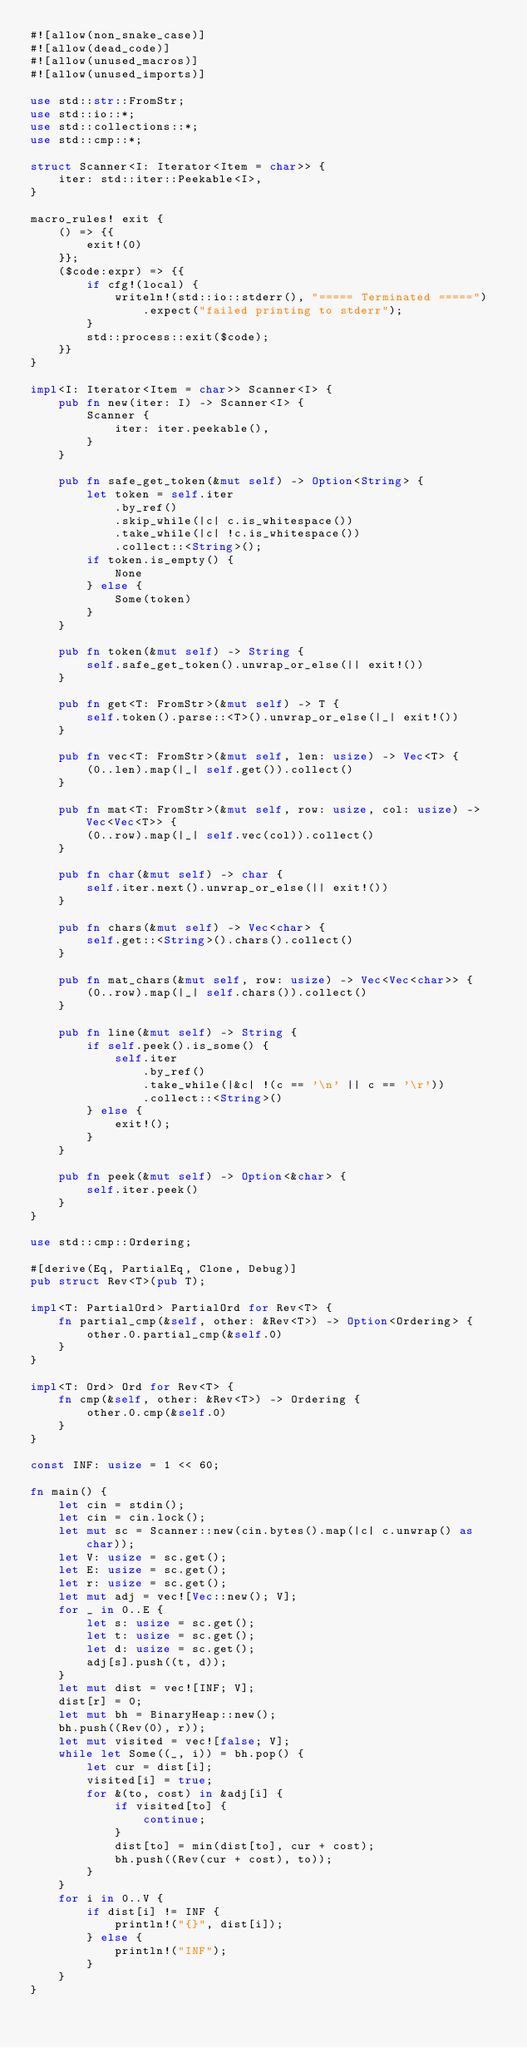<code> <loc_0><loc_0><loc_500><loc_500><_Rust_>#![allow(non_snake_case)]
#![allow(dead_code)]
#![allow(unused_macros)]
#![allow(unused_imports)]

use std::str::FromStr;
use std::io::*;
use std::collections::*;
use std::cmp::*;

struct Scanner<I: Iterator<Item = char>> {
    iter: std::iter::Peekable<I>,
}

macro_rules! exit {
    () => {{
        exit!(0)
    }};
    ($code:expr) => {{
        if cfg!(local) {
            writeln!(std::io::stderr(), "===== Terminated =====")
                .expect("failed printing to stderr");
        }
        std::process::exit($code);
    }}
}

impl<I: Iterator<Item = char>> Scanner<I> {
    pub fn new(iter: I) -> Scanner<I> {
        Scanner {
            iter: iter.peekable(),
        }
    }

    pub fn safe_get_token(&mut self) -> Option<String> {
        let token = self.iter
            .by_ref()
            .skip_while(|c| c.is_whitespace())
            .take_while(|c| !c.is_whitespace())
            .collect::<String>();
        if token.is_empty() {
            None
        } else {
            Some(token)
        }
    }

    pub fn token(&mut self) -> String {
        self.safe_get_token().unwrap_or_else(|| exit!())
    }

    pub fn get<T: FromStr>(&mut self) -> T {
        self.token().parse::<T>().unwrap_or_else(|_| exit!())
    }

    pub fn vec<T: FromStr>(&mut self, len: usize) -> Vec<T> {
        (0..len).map(|_| self.get()).collect()
    }

    pub fn mat<T: FromStr>(&mut self, row: usize, col: usize) -> Vec<Vec<T>> {
        (0..row).map(|_| self.vec(col)).collect()
    }

    pub fn char(&mut self) -> char {
        self.iter.next().unwrap_or_else(|| exit!())
    }

    pub fn chars(&mut self) -> Vec<char> {
        self.get::<String>().chars().collect()
    }

    pub fn mat_chars(&mut self, row: usize) -> Vec<Vec<char>> {
        (0..row).map(|_| self.chars()).collect()
    }

    pub fn line(&mut self) -> String {
        if self.peek().is_some() {
            self.iter
                .by_ref()
                .take_while(|&c| !(c == '\n' || c == '\r'))
                .collect::<String>()
        } else {
            exit!();
        }
    }

    pub fn peek(&mut self) -> Option<&char> {
        self.iter.peek()
    }
}

use std::cmp::Ordering;

#[derive(Eq, PartialEq, Clone, Debug)]
pub struct Rev<T>(pub T);

impl<T: PartialOrd> PartialOrd for Rev<T> {
    fn partial_cmp(&self, other: &Rev<T>) -> Option<Ordering> {
        other.0.partial_cmp(&self.0)
    }
}

impl<T: Ord> Ord for Rev<T> {
    fn cmp(&self, other: &Rev<T>) -> Ordering {
        other.0.cmp(&self.0)
    }
}

const INF: usize = 1 << 60;

fn main() {
    let cin = stdin();
    let cin = cin.lock();
    let mut sc = Scanner::new(cin.bytes().map(|c| c.unwrap() as char));
    let V: usize = sc.get();
    let E: usize = sc.get();
    let r: usize = sc.get();
    let mut adj = vec![Vec::new(); V];
    for _ in 0..E {
        let s: usize = sc.get();
        let t: usize = sc.get();
        let d: usize = sc.get();
        adj[s].push((t, d));
    }
    let mut dist = vec![INF; V];
    dist[r] = 0;
    let mut bh = BinaryHeap::new();
    bh.push((Rev(0), r));
    let mut visited = vec![false; V];
    while let Some((_, i)) = bh.pop() {
        let cur = dist[i];
        visited[i] = true;
        for &(to, cost) in &adj[i] {
            if visited[to] {
                continue;
            }
            dist[to] = min(dist[to], cur + cost);
            bh.push((Rev(cur + cost), to));
        }
    }
    for i in 0..V {
        if dist[i] != INF {
            println!("{}", dist[i]);
        } else {
            println!("INF");
        }
    }
}

</code> 